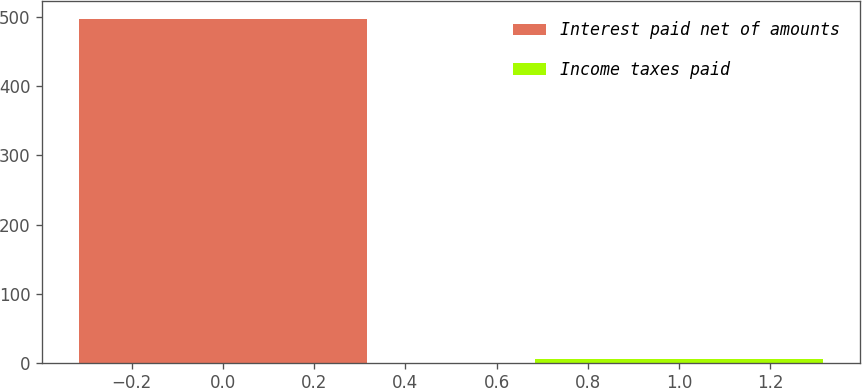Convert chart. <chart><loc_0><loc_0><loc_500><loc_500><bar_chart><fcel>Interest paid net of amounts<fcel>Income taxes paid<nl><fcel>498<fcel>5<nl></chart> 